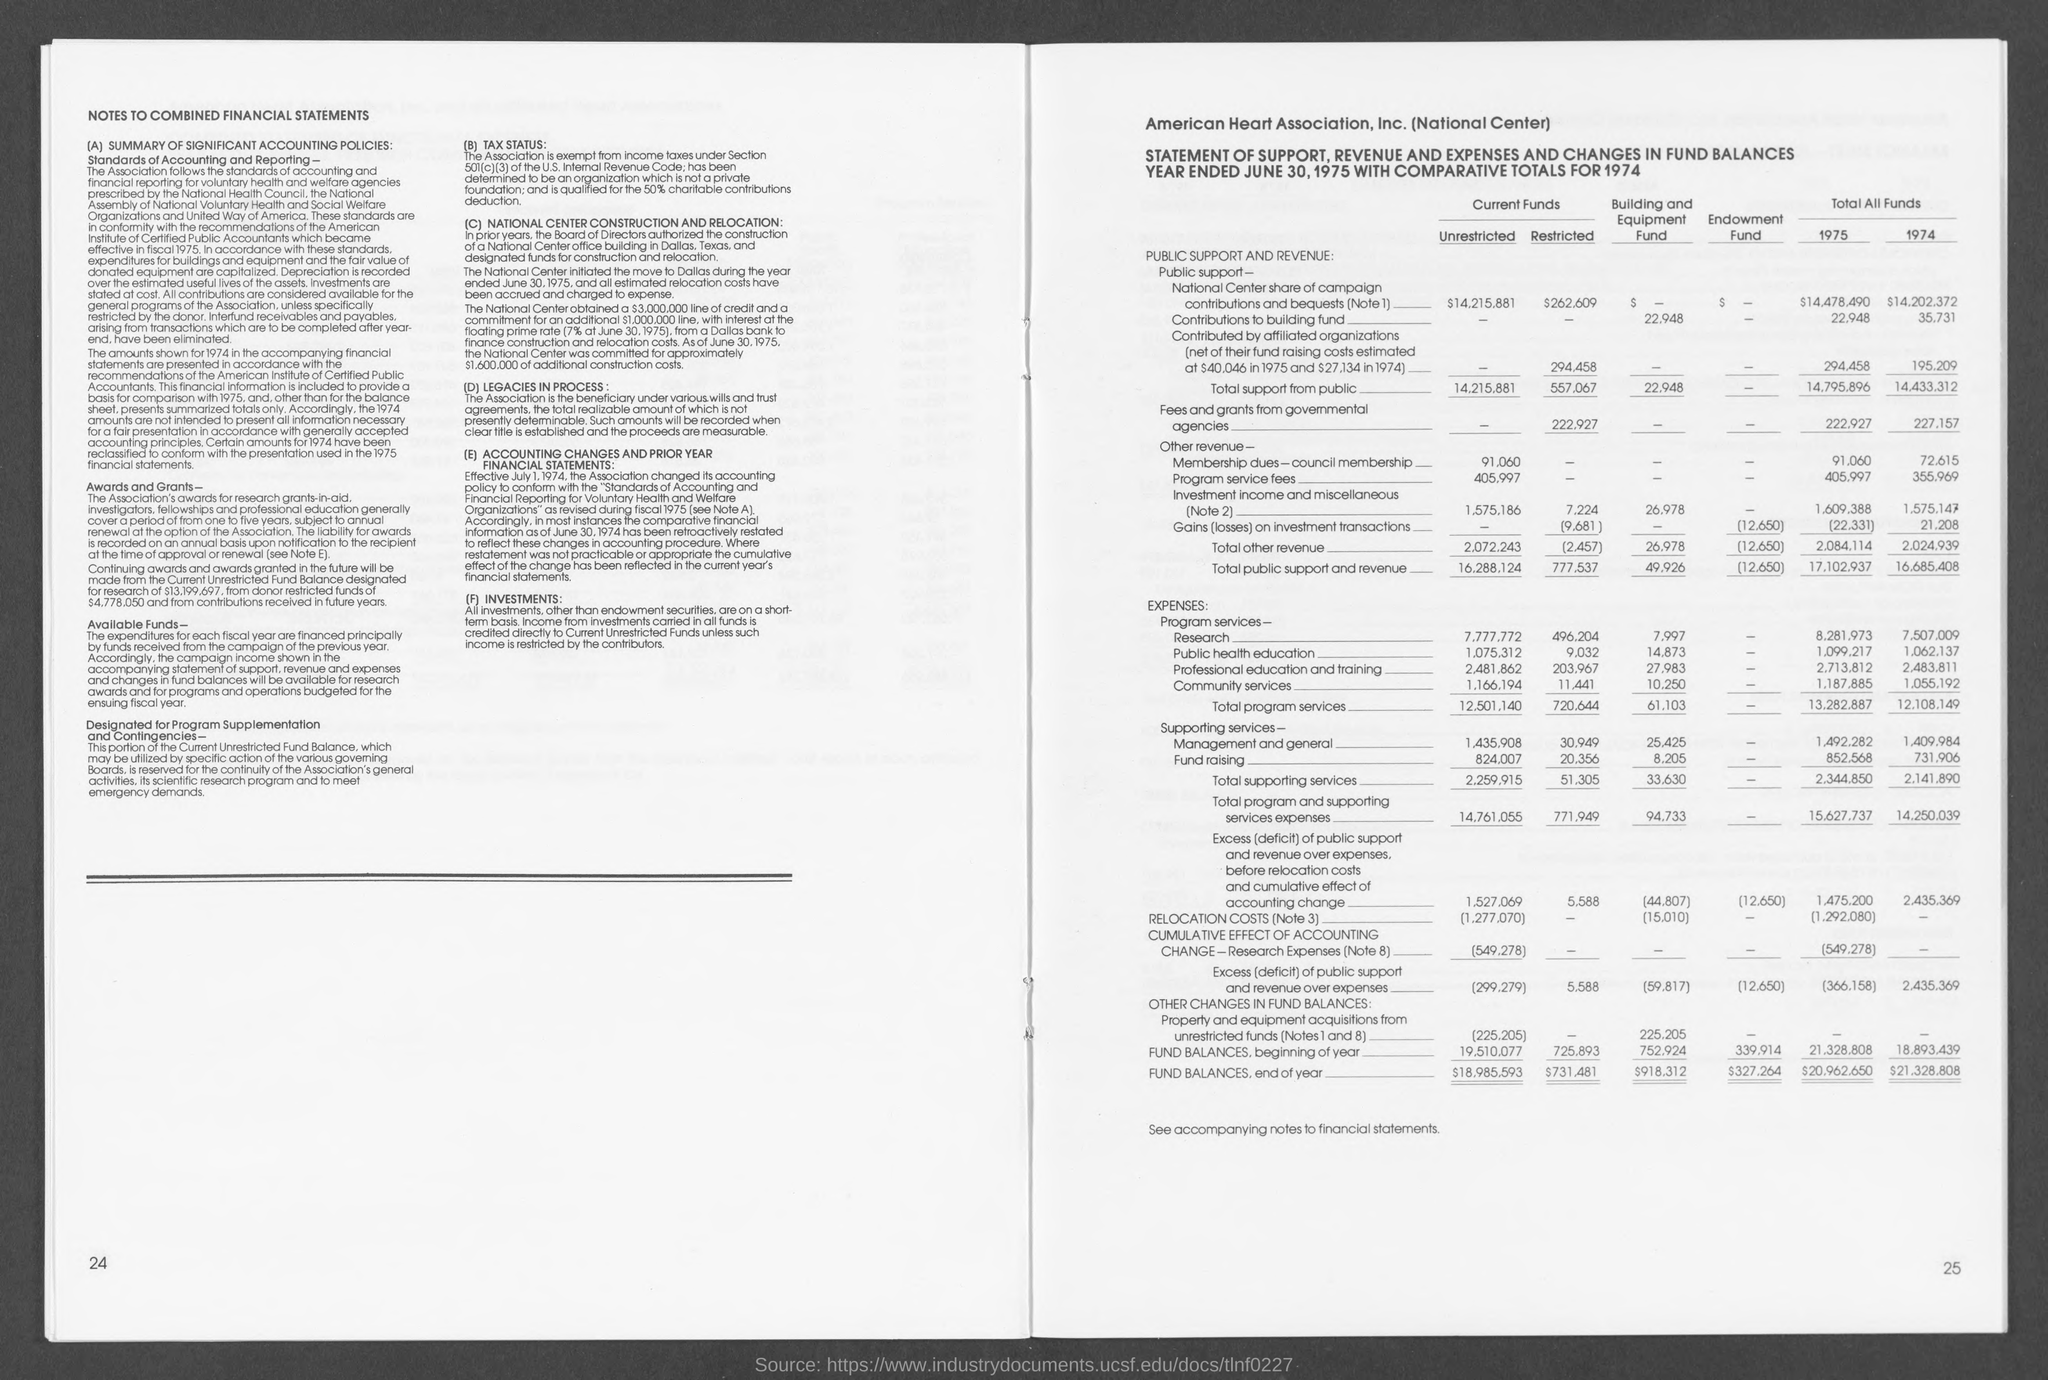What is the heading of the first page?
Provide a succinct answer. Notes to combined financial statements. What is the association's awards subject to?
Keep it short and to the point. Subject to annual renewal at the option of the association. To which year is the statement compared to?
Give a very brief answer. 1974. 